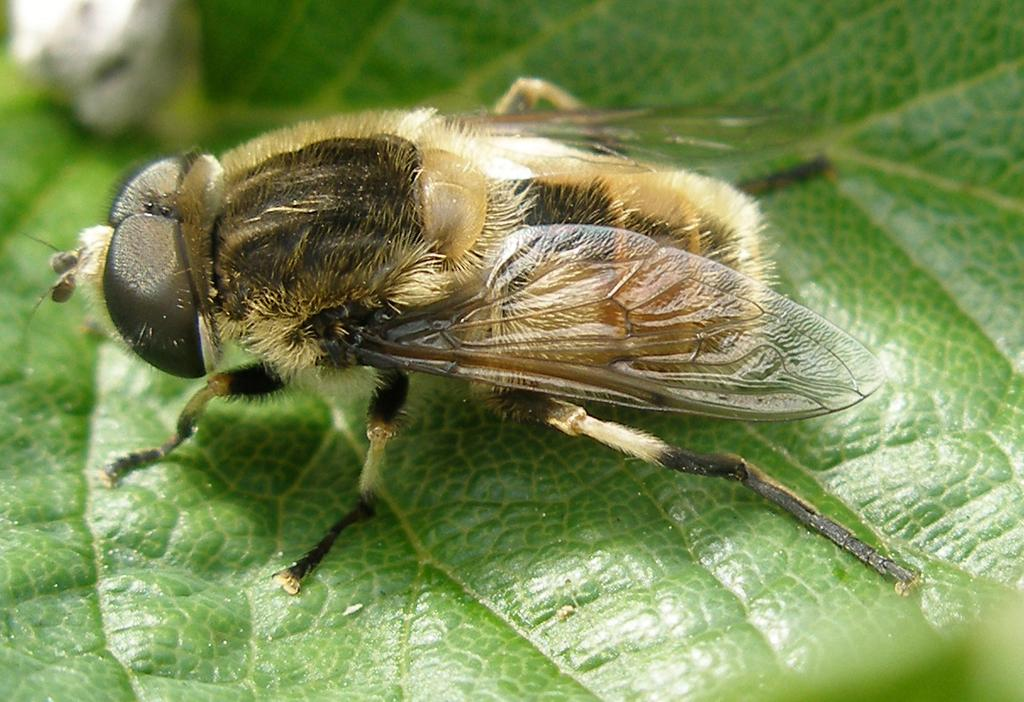What type of insect is present in the image? There is a housefly in the image. What can be seen in the background of the image? There are green leaves in the background of the image. Can you describe the object towards the top of the image? Unfortunately, the provided facts do not give enough information to describe the object towards the top of the image. What type of volleyball is being cooked in the image? There is no volleyball or cooking activity present in the image. 